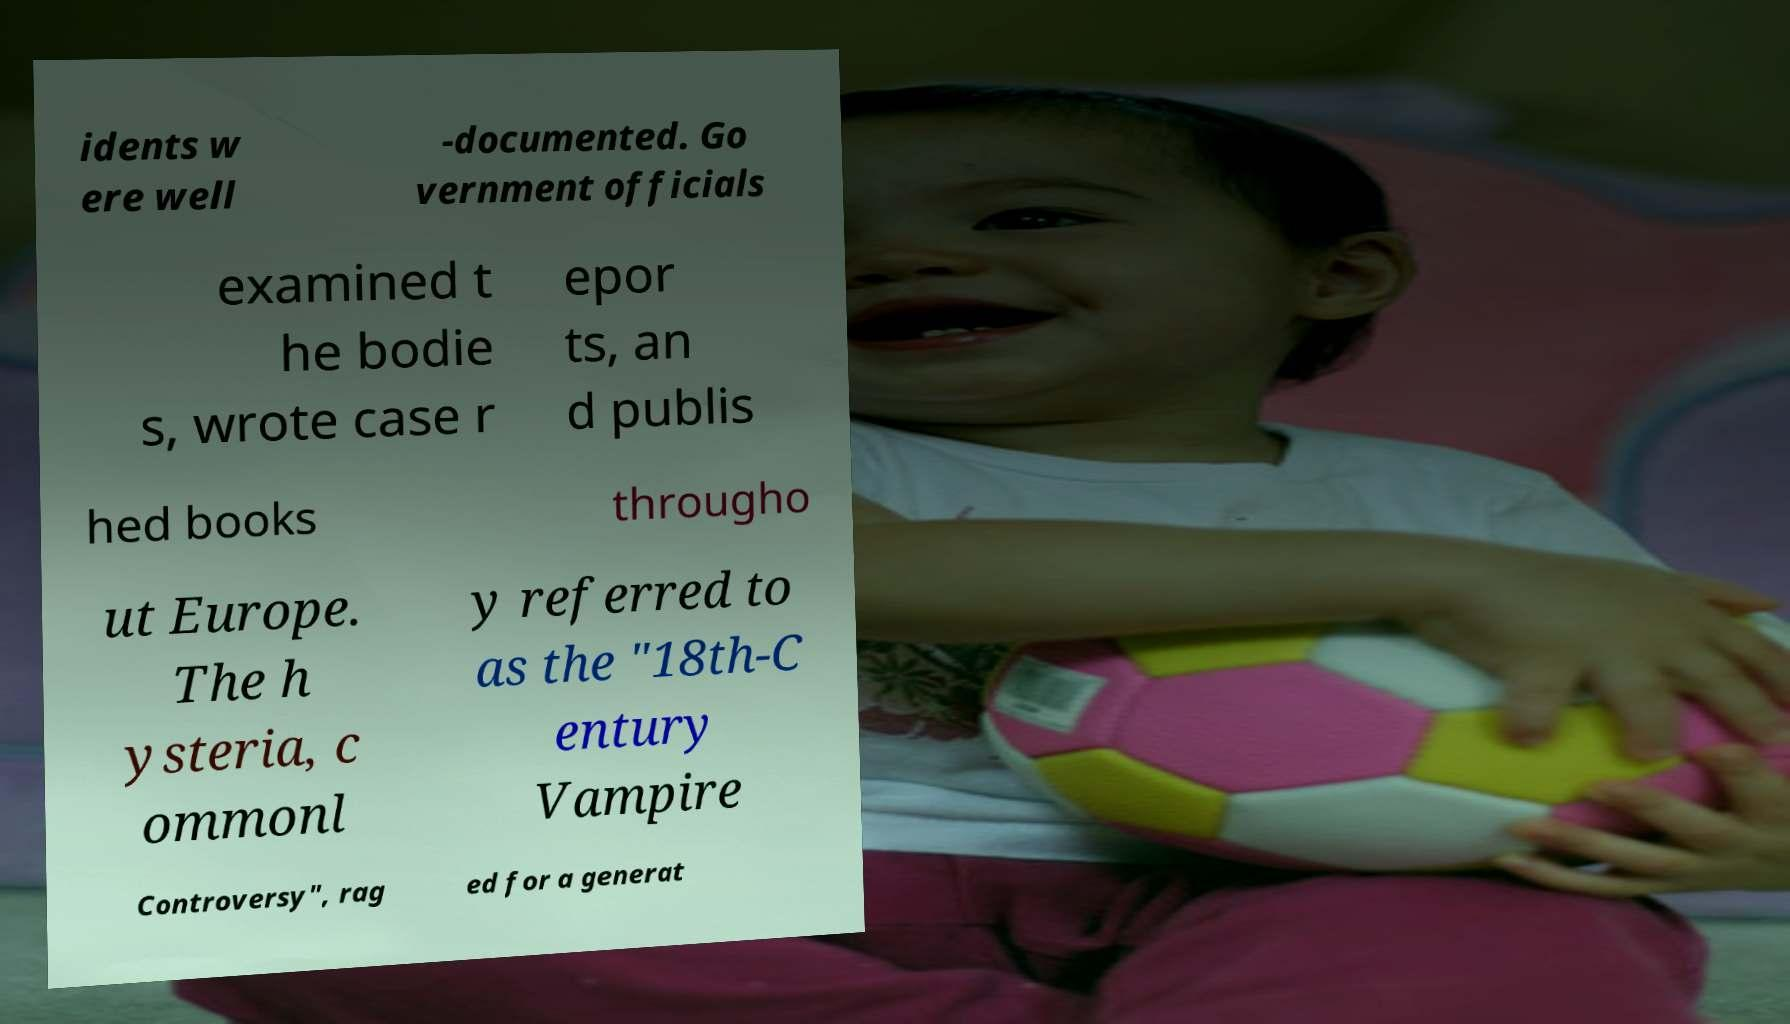Could you extract and type out the text from this image? idents w ere well -documented. Go vernment officials examined t he bodie s, wrote case r epor ts, an d publis hed books througho ut Europe. The h ysteria, c ommonl y referred to as the "18th-C entury Vampire Controversy", rag ed for a generat 